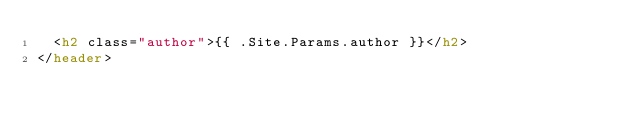Convert code to text. <code><loc_0><loc_0><loc_500><loc_500><_HTML_>  <h2 class="author">{{ .Site.Params.author }}</h2>
</header>
</code> 